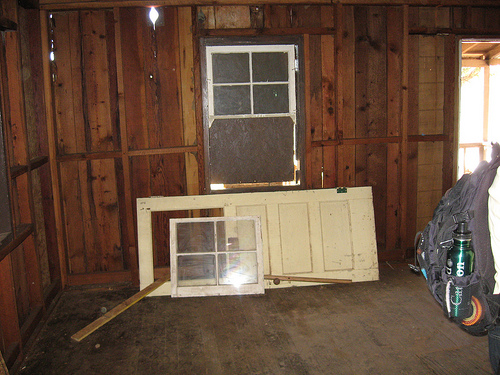<image>
Is there a window in the door? No. The window is not contained within the door. These objects have a different spatial relationship. 